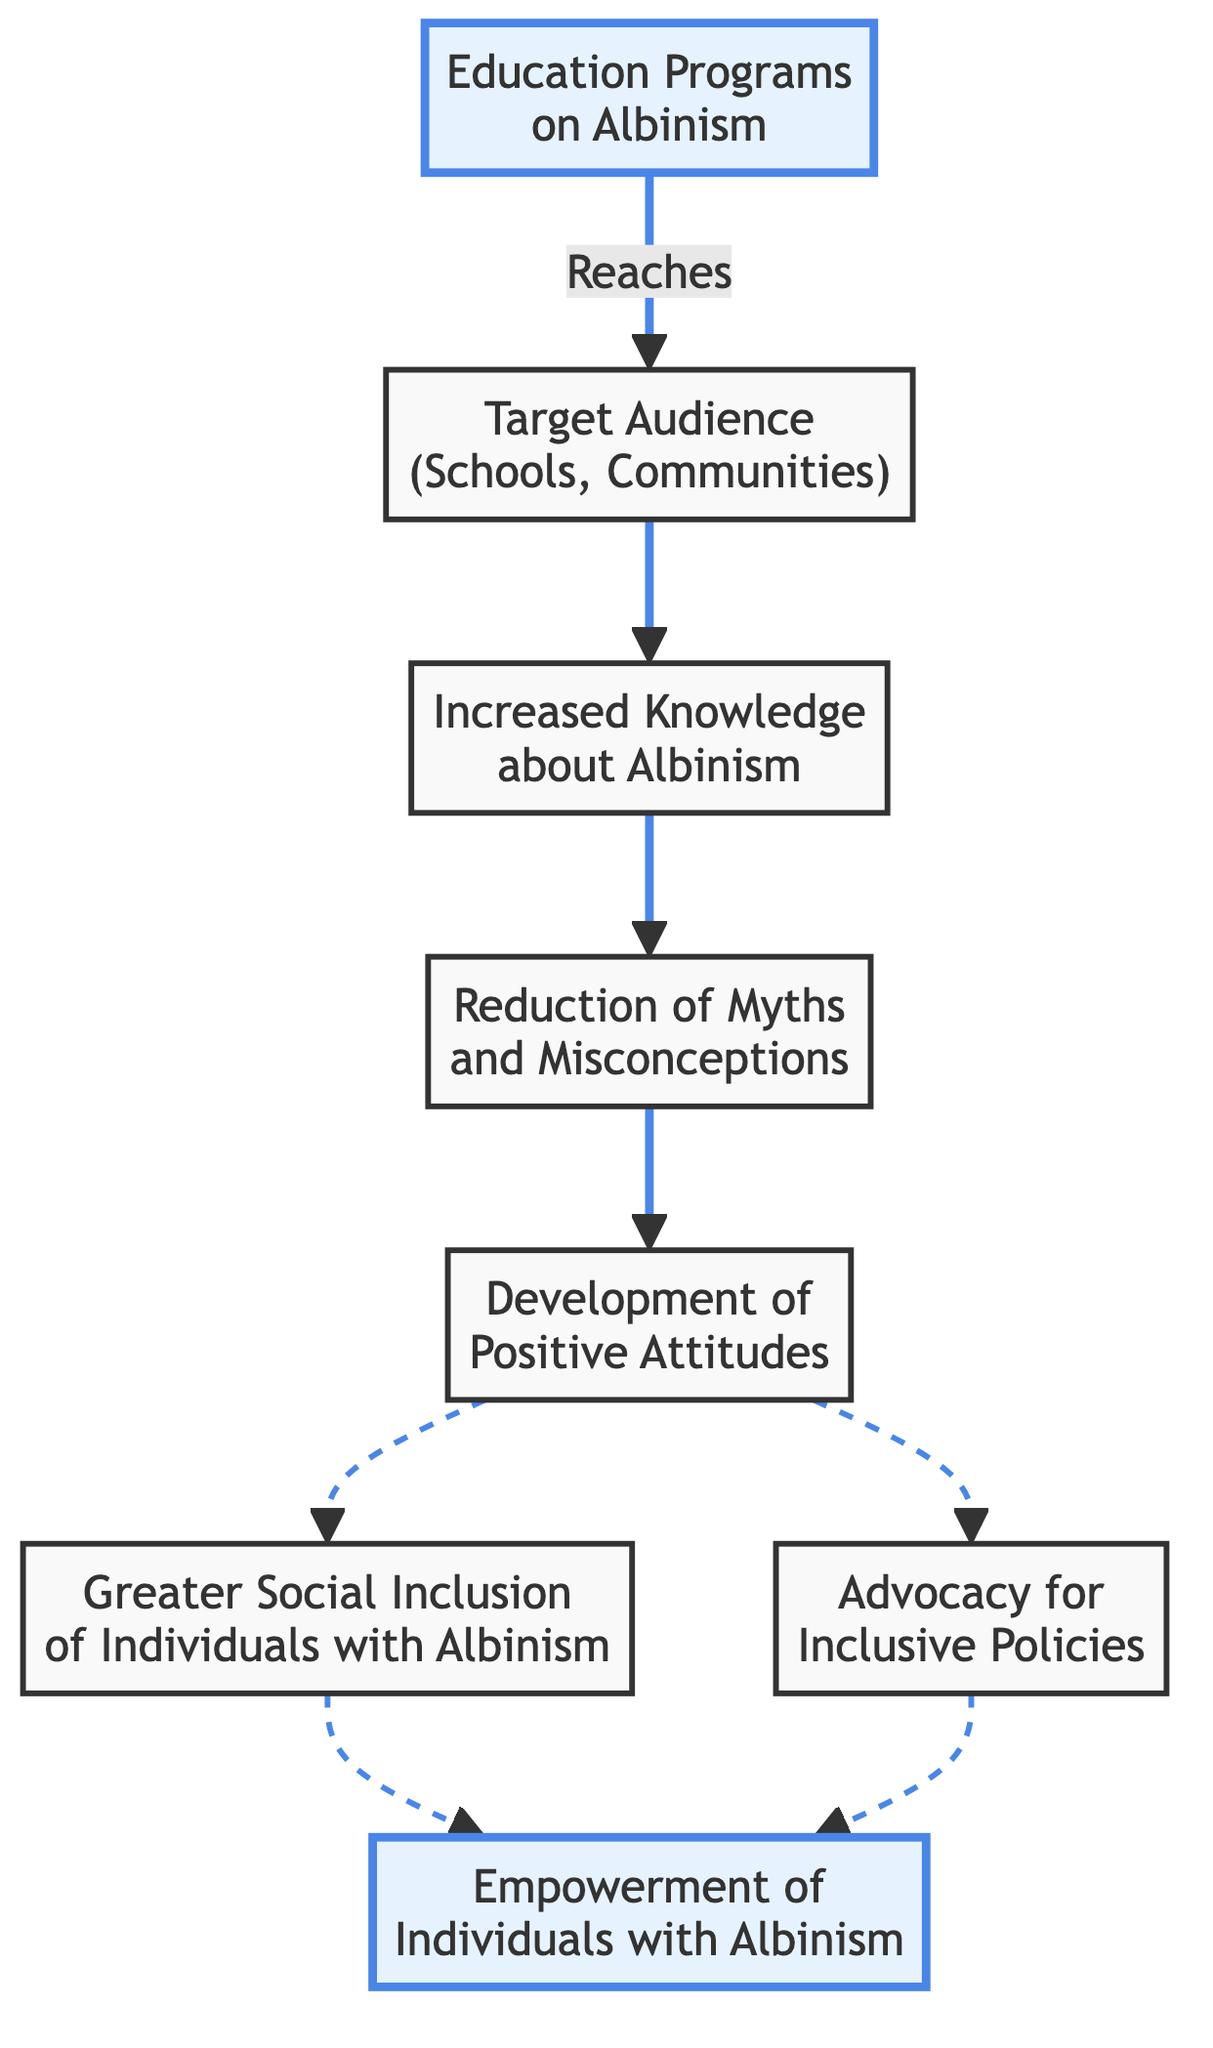What is the first node in the flowchart? The first node is "Education Programs on Albinism," indicating the starting point of the awareness campaign.
Answer: Education Programs on Albinism How many nodes are there in total? By counting the individual nodes listed in the data, there are 8 nodes present in the diagram.
Answer: 8 What does the "Target Audience" node connect to? The "Target Audience" node connects to the "Increased Knowledge" node, showing the flow from the audience receiving educational programs to gaining knowledge.
Answer: Increased Knowledge What are the two outcomes of "Positive Attitudes"? The two outcomes are "Greater Social Inclusion of Individuals with Albinism" and "Advocacy for Inclusive Policies," indicating the beneficial results of developing positive attitudes.
Answer: Greater Social Inclusion, Advocacy for Inclusive Policies Which node leads directly to "Empowerment"? "Social Inclusion" and "Policy Advocacy" both lead directly to "Empowerment," highlighting how these two aspects contribute to empowering individuals with albinism.
Answer: Social Inclusion, Policy Advocacy What is the relationship between "Increased Knowledge" and "Reduction of Myths"? "Increased Knowledge" leads to "Reduction of Myths and Misconceptions," indicating that greater knowledge results in fewer misconceptions about albinism.
Answer: Reduction of Myths and Misconceptions How many edges are in the diagram? There are 8 edges that represent the connections between the nodes, showing the flow of influence from one aspect to another.
Answer: 8 Which node has the most connections (outgoing edges)? "Positive Attitudes" has two outgoing edges, connecting to both "Social Inclusion" and "Policy Advocacy," indicating its significant role in the campaign.
Answer: Positive Attitudes What connects "Education Programs on Albinism" to "Target Audience"? The edge labeled "Reaches" indicates the connection between "Education Programs on Albinism" and the "Target Audience."
Answer: Reaches 